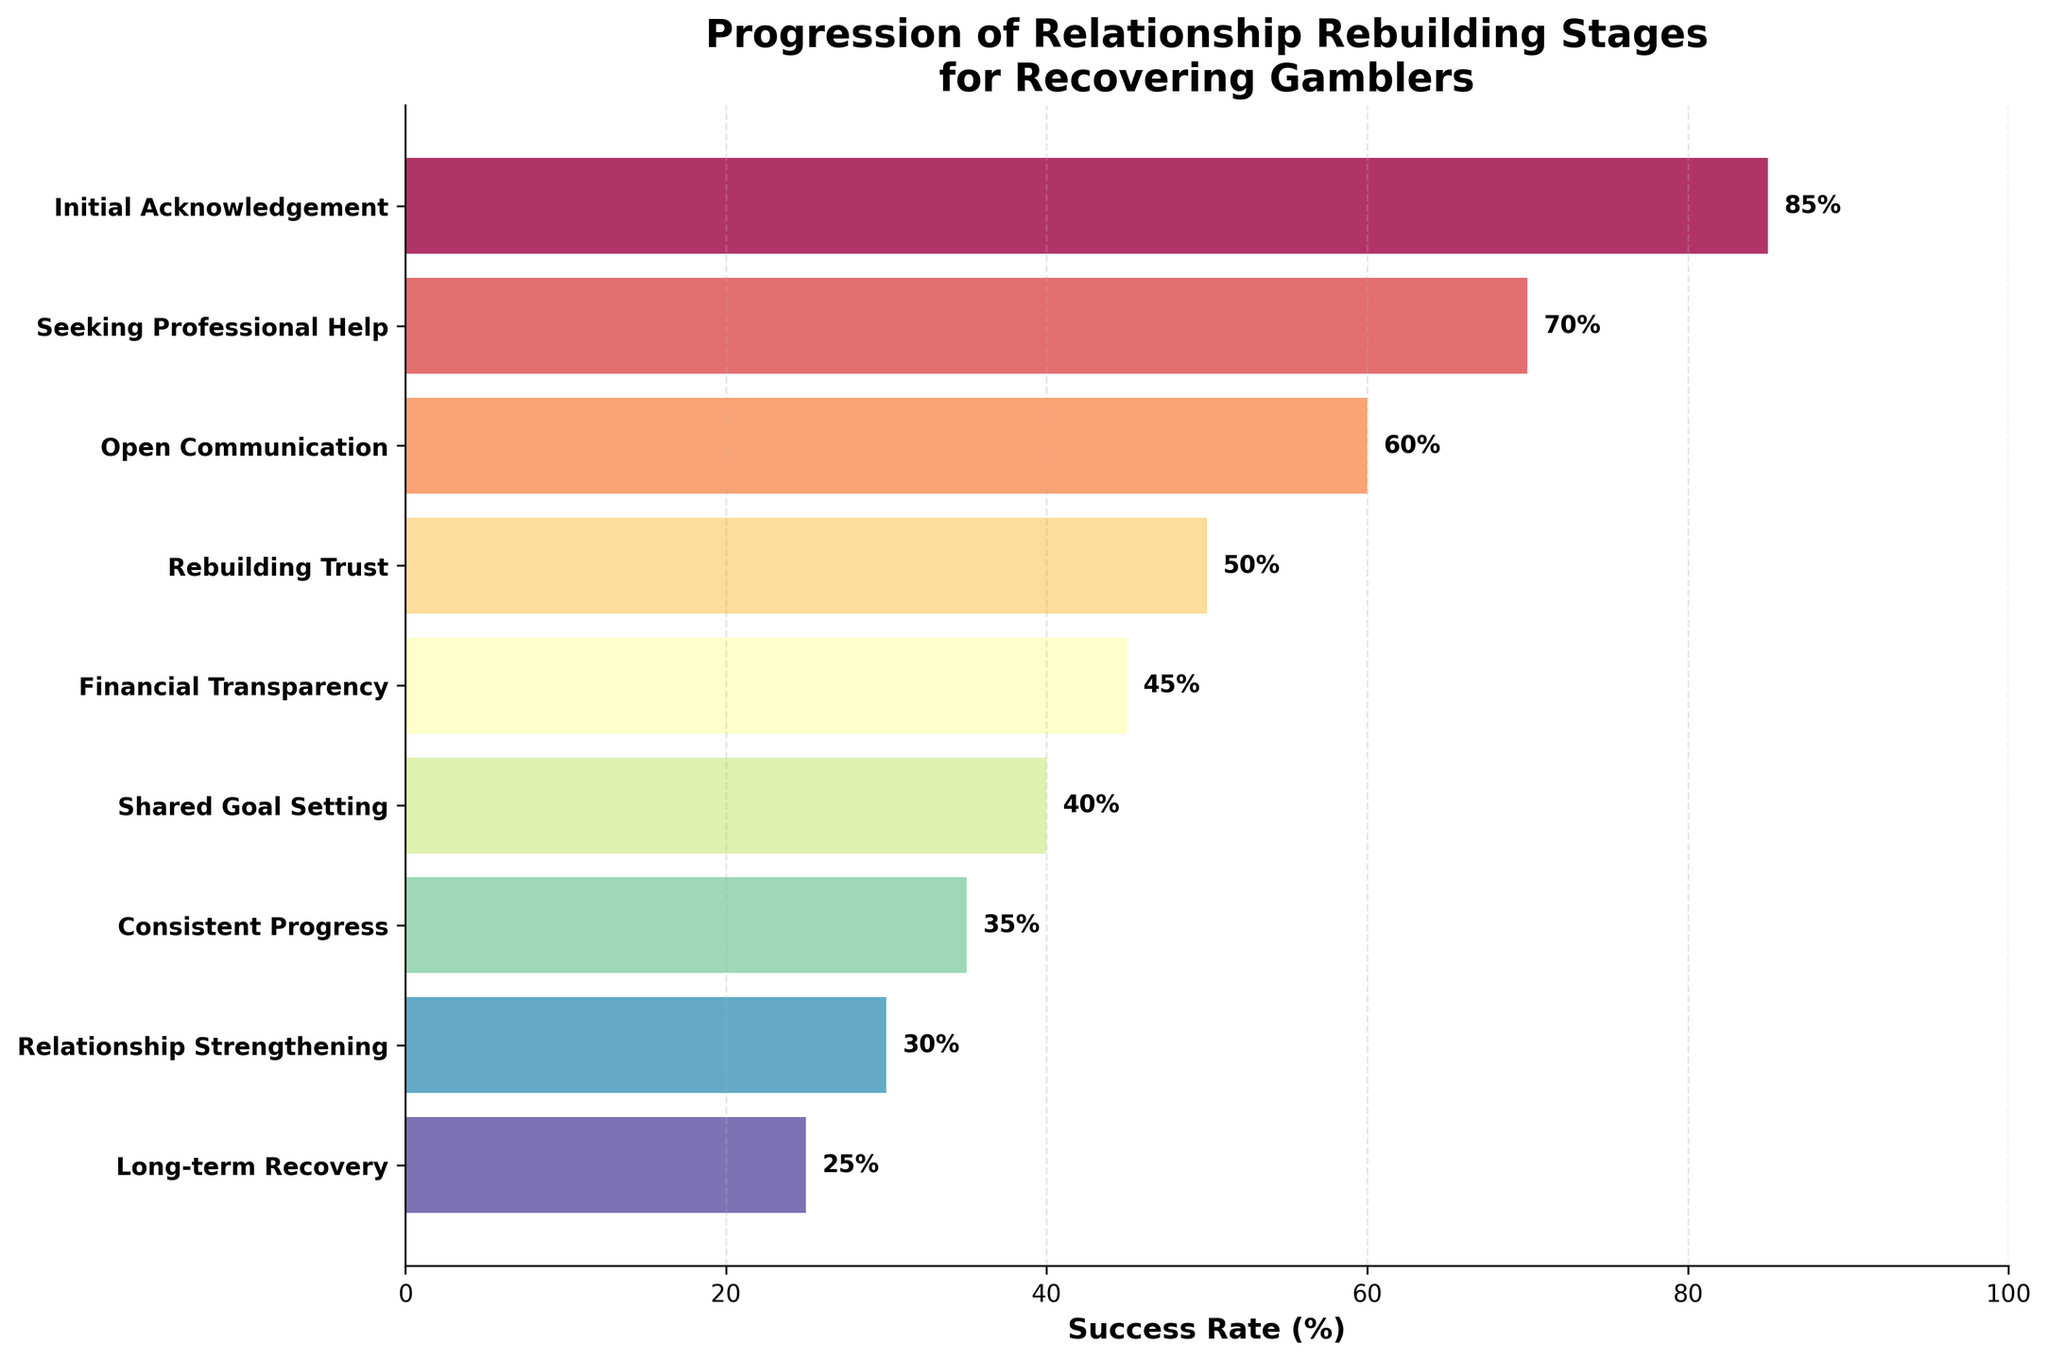What’s the title of the chart? The title is prominently displayed at the top of the chart. It reads "Progression of Relationship Rebuilding Stages for Recovering Gamblers".
Answer: Progression of Relationship Rebuilding Stages for Recovering Gamblers What’s the success rate for the "Seeking Professional Help" stage? According to the chart, each stage has a corresponding success rate next to its bar. The success rate for "Seeking Professional Help" is indicated as 70%.
Answer: 70% Which stage has the lowest success rate and what is the rate? To determine this, we inspect the bars on the chart and their corresponding success rates. The shortest bar at the bottom corresponds to the "Long-term Recovery" stage, which has a success rate of 25%.
Answer: Long-term Recovery, 25% How many stages are represented in the funnel chart? By counting the number of bars listed from top to bottom, we see there are nine stages represented.
Answer: Nine Which stage has a success rate between 40% and 50%? Looking at the chart, we can find that "Financial Transparency" has a success rate of 45%, which falls within the 40% to 50% range.
Answer: Financial Transparency How much higher is the success rate for "Rebuilding Trust" compared to "Consistent Progress"? The success rate for "Rebuilding Trust" is 50% and for "Consistent Progress" is 35%. By subtracting 35 from 50, we find that "Rebuilding Trust" is 15 percentage points higher.
Answer: 15 percentage points What's the difference in success rates between the "Initial Acknowledgement" stage and the "Relationship Strengthening" stage? The success rate for "Initial Acknowledgement" is 85% and for "Relationship Strengthening" it is 30%. Subtracting 30 from 85, we get a difference of 55 percentage points.
Answer: 55 percentage points Are there any stages where the success rate drops by more than 20% from the previous stage? If yes, name one. By analyzing the successive stages, the largest drop appears between "Initial Acknowledgement" (85%) and "Seeking Professional Help" (70%), which is a 15% drop. Therefore, none has more than 20% drop.
Answer: No What is the cumulative success rate at the "Open Communication" stage if each previous stage’s success adds to the next one without any loss? Starting from "Initial Acknowledgement" (85%), adding "Seeking Professional Help" (70%) gives 155%, then adding "Open Communication" (60%) totals to 215%.
Answer: 215% What does the visualization suggest about the overall trend in success rates across the stages? The chart shows a clear downward trend in success rates as the stages progress from "Initial Acknowledgement" (85%) to "Long-term Recovery" (25%).
Answer: Downward trend 